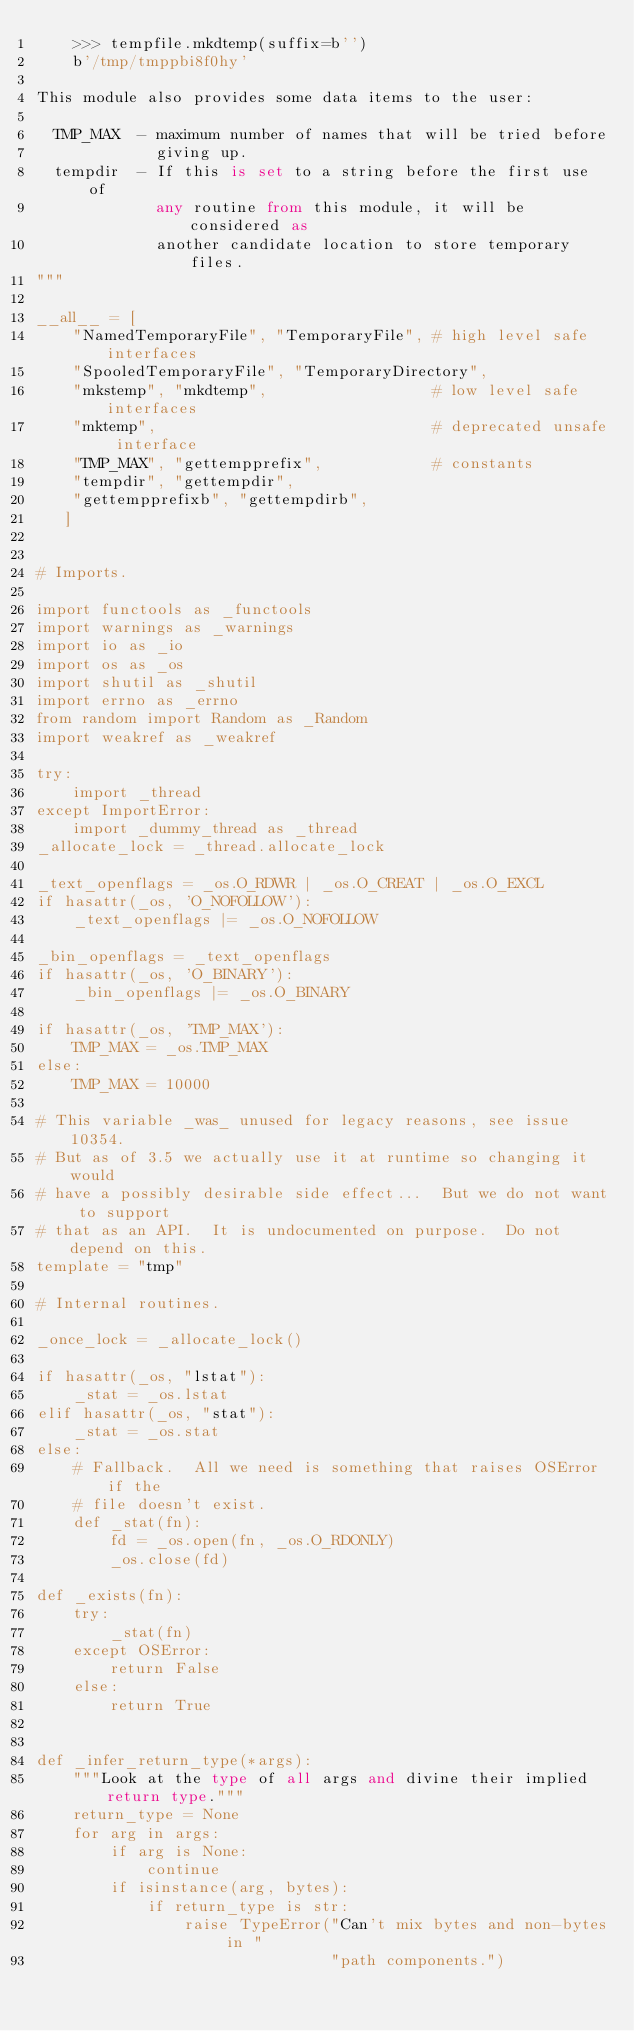Convert code to text. <code><loc_0><loc_0><loc_500><loc_500><_Python_>    >>> tempfile.mkdtemp(suffix=b'')
    b'/tmp/tmppbi8f0hy'

This module also provides some data items to the user:

  TMP_MAX  - maximum number of names that will be tried before
             giving up.
  tempdir  - If this is set to a string before the first use of
             any routine from this module, it will be considered as
             another candidate location to store temporary files.
"""

__all__ = [
    "NamedTemporaryFile", "TemporaryFile", # high level safe interfaces
    "SpooledTemporaryFile", "TemporaryDirectory",
    "mkstemp", "mkdtemp",                  # low level safe interfaces
    "mktemp",                              # deprecated unsafe interface
    "TMP_MAX", "gettempprefix",            # constants
    "tempdir", "gettempdir",
    "gettempprefixb", "gettempdirb",
   ]


# Imports.

import functools as _functools
import warnings as _warnings
import io as _io
import os as _os
import shutil as _shutil
import errno as _errno
from random import Random as _Random
import weakref as _weakref

try:
    import _thread
except ImportError:
    import _dummy_thread as _thread
_allocate_lock = _thread.allocate_lock

_text_openflags = _os.O_RDWR | _os.O_CREAT | _os.O_EXCL
if hasattr(_os, 'O_NOFOLLOW'):
    _text_openflags |= _os.O_NOFOLLOW

_bin_openflags = _text_openflags
if hasattr(_os, 'O_BINARY'):
    _bin_openflags |= _os.O_BINARY

if hasattr(_os, 'TMP_MAX'):
    TMP_MAX = _os.TMP_MAX
else:
    TMP_MAX = 10000

# This variable _was_ unused for legacy reasons, see issue 10354.
# But as of 3.5 we actually use it at runtime so changing it would
# have a possibly desirable side effect...  But we do not want to support
# that as an API.  It is undocumented on purpose.  Do not depend on this.
template = "tmp"

# Internal routines.

_once_lock = _allocate_lock()

if hasattr(_os, "lstat"):
    _stat = _os.lstat
elif hasattr(_os, "stat"):
    _stat = _os.stat
else:
    # Fallback.  All we need is something that raises OSError if the
    # file doesn't exist.
    def _stat(fn):
        fd = _os.open(fn, _os.O_RDONLY)
        _os.close(fd)

def _exists(fn):
    try:
        _stat(fn)
    except OSError:
        return False
    else:
        return True


def _infer_return_type(*args):
    """Look at the type of all args and divine their implied return type."""
    return_type = None
    for arg in args:
        if arg is None:
            continue
        if isinstance(arg, bytes):
            if return_type is str:
                raise TypeError("Can't mix bytes and non-bytes in "
                                "path components.")</code> 